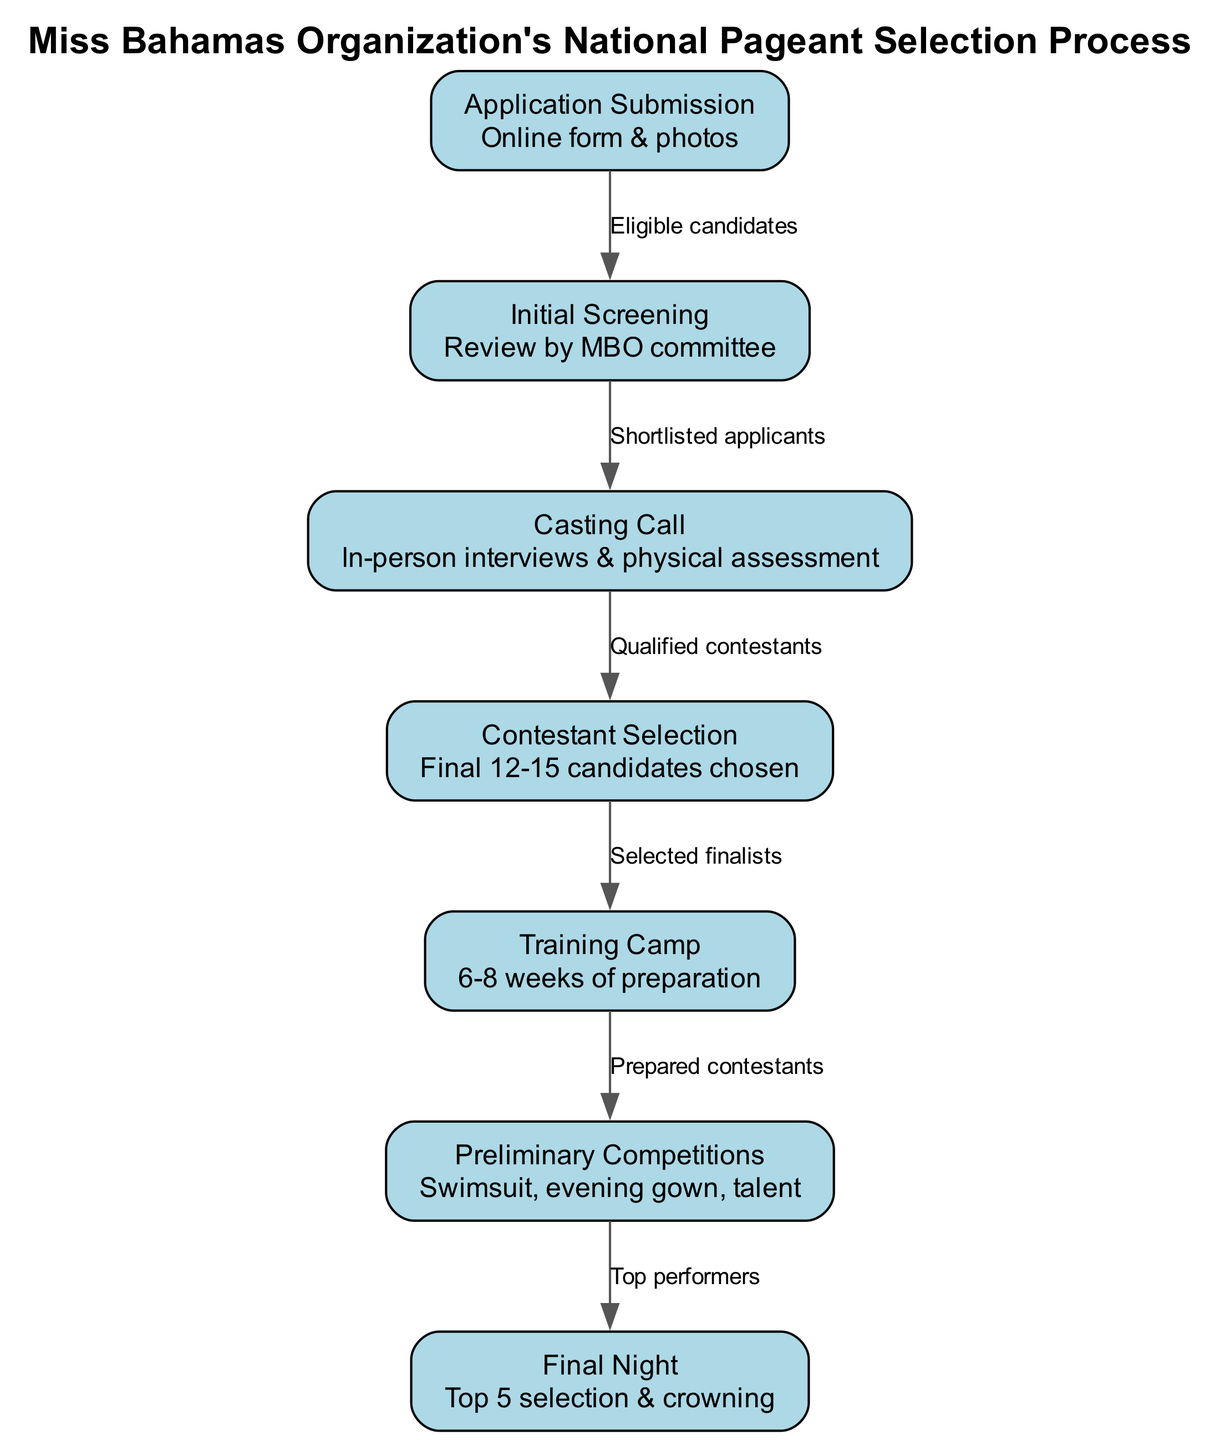What is the first step in the selection process? The first step in the selection process is "Application Submission," where eligible candidates fill out an online form and submit photos.
Answer: Application Submission How many candidates are selected after the "Contestant Selection"? After the "Contestant Selection," 12-15 candidates are chosen as finalists.
Answer: 12-15 candidates What is the relationship between "Casting Call" and "Initial Screening"? "Casting Call" follows "Initial Screening," which means it occurs after the shortlisted applicants have been identified by the MBO committee.
Answer: Shortlisted applicants What is the total number of nodes in the diagram? The total number of nodes is determined by counting all distinct actions or stages in the selection process, which yields seven.
Answer: 7 What do the "Preliminary Competitions" consist of? The "Preliminary Competitions" consist of three segments: swimsuit, evening gown, and talent.
Answer: Swimsuit, evening gown, talent Which stage involves in-person interviews? The stage that involves in-person interviews is the "Casting Call," where candidates undergo assessments and interviews.
Answer: Casting Call What must candidates achieve to move from "Preliminary Competitions" to "Final Night"? Candidates must be among the top performers in the preliminary competitions to advance to the final night.
Answer: Top performers What duration of preparation is allocated in the "Training Camp"? The preparation in the "Training Camp" lasts for 6-8 weeks, as indicated in the details of that node.
Answer: 6-8 weeks What is the final result of the "Final Night"? The final result of the "Final Night" is the selection of the top 5 candidates and crowning of the winner.
Answer: Top 5 selection & crowning 